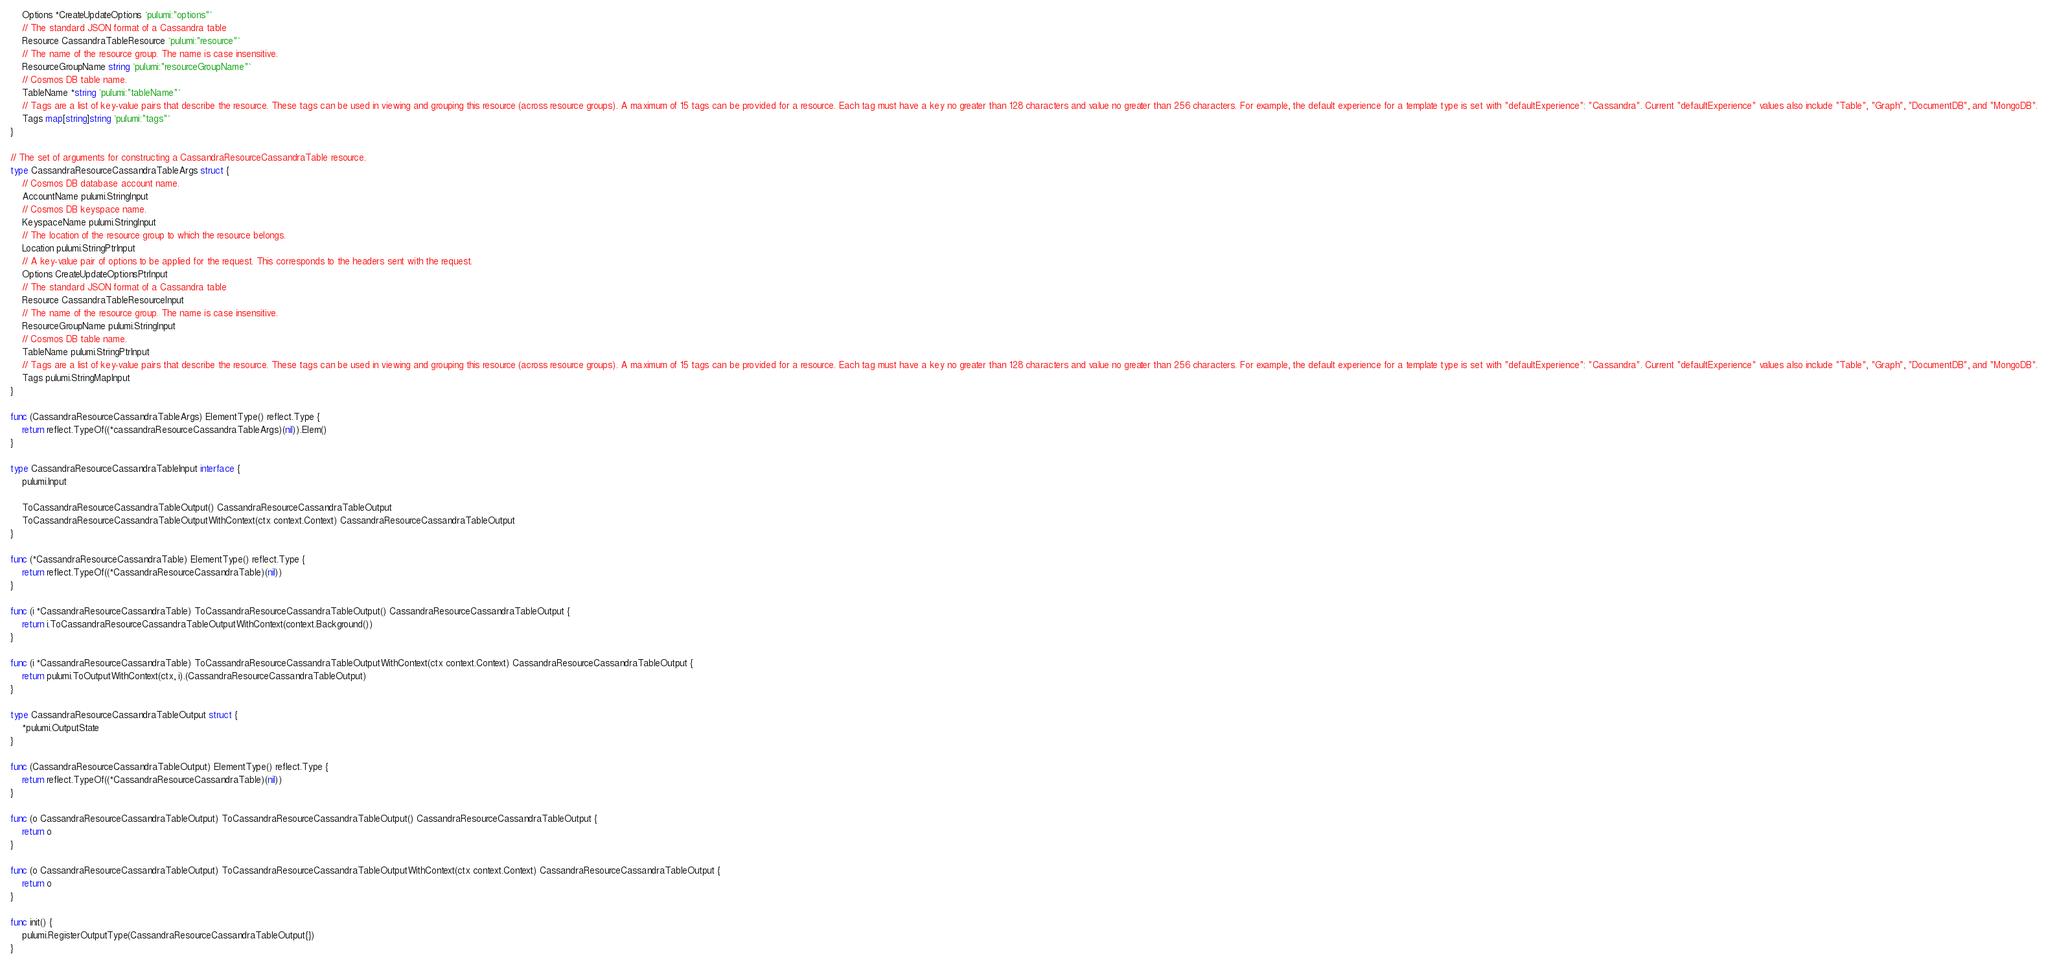<code> <loc_0><loc_0><loc_500><loc_500><_Go_>	Options *CreateUpdateOptions `pulumi:"options"`
	// The standard JSON format of a Cassandra table
	Resource CassandraTableResource `pulumi:"resource"`
	// The name of the resource group. The name is case insensitive.
	ResourceGroupName string `pulumi:"resourceGroupName"`
	// Cosmos DB table name.
	TableName *string `pulumi:"tableName"`
	// Tags are a list of key-value pairs that describe the resource. These tags can be used in viewing and grouping this resource (across resource groups). A maximum of 15 tags can be provided for a resource. Each tag must have a key no greater than 128 characters and value no greater than 256 characters. For example, the default experience for a template type is set with "defaultExperience": "Cassandra". Current "defaultExperience" values also include "Table", "Graph", "DocumentDB", and "MongoDB".
	Tags map[string]string `pulumi:"tags"`
}

// The set of arguments for constructing a CassandraResourceCassandraTable resource.
type CassandraResourceCassandraTableArgs struct {
	// Cosmos DB database account name.
	AccountName pulumi.StringInput
	// Cosmos DB keyspace name.
	KeyspaceName pulumi.StringInput
	// The location of the resource group to which the resource belongs.
	Location pulumi.StringPtrInput
	// A key-value pair of options to be applied for the request. This corresponds to the headers sent with the request.
	Options CreateUpdateOptionsPtrInput
	// The standard JSON format of a Cassandra table
	Resource CassandraTableResourceInput
	// The name of the resource group. The name is case insensitive.
	ResourceGroupName pulumi.StringInput
	// Cosmos DB table name.
	TableName pulumi.StringPtrInput
	// Tags are a list of key-value pairs that describe the resource. These tags can be used in viewing and grouping this resource (across resource groups). A maximum of 15 tags can be provided for a resource. Each tag must have a key no greater than 128 characters and value no greater than 256 characters. For example, the default experience for a template type is set with "defaultExperience": "Cassandra". Current "defaultExperience" values also include "Table", "Graph", "DocumentDB", and "MongoDB".
	Tags pulumi.StringMapInput
}

func (CassandraResourceCassandraTableArgs) ElementType() reflect.Type {
	return reflect.TypeOf((*cassandraResourceCassandraTableArgs)(nil)).Elem()
}

type CassandraResourceCassandraTableInput interface {
	pulumi.Input

	ToCassandraResourceCassandraTableOutput() CassandraResourceCassandraTableOutput
	ToCassandraResourceCassandraTableOutputWithContext(ctx context.Context) CassandraResourceCassandraTableOutput
}

func (*CassandraResourceCassandraTable) ElementType() reflect.Type {
	return reflect.TypeOf((*CassandraResourceCassandraTable)(nil))
}

func (i *CassandraResourceCassandraTable) ToCassandraResourceCassandraTableOutput() CassandraResourceCassandraTableOutput {
	return i.ToCassandraResourceCassandraTableOutputWithContext(context.Background())
}

func (i *CassandraResourceCassandraTable) ToCassandraResourceCassandraTableOutputWithContext(ctx context.Context) CassandraResourceCassandraTableOutput {
	return pulumi.ToOutputWithContext(ctx, i).(CassandraResourceCassandraTableOutput)
}

type CassandraResourceCassandraTableOutput struct {
	*pulumi.OutputState
}

func (CassandraResourceCassandraTableOutput) ElementType() reflect.Type {
	return reflect.TypeOf((*CassandraResourceCassandraTable)(nil))
}

func (o CassandraResourceCassandraTableOutput) ToCassandraResourceCassandraTableOutput() CassandraResourceCassandraTableOutput {
	return o
}

func (o CassandraResourceCassandraTableOutput) ToCassandraResourceCassandraTableOutputWithContext(ctx context.Context) CassandraResourceCassandraTableOutput {
	return o
}

func init() {
	pulumi.RegisterOutputType(CassandraResourceCassandraTableOutput{})
}
</code> 